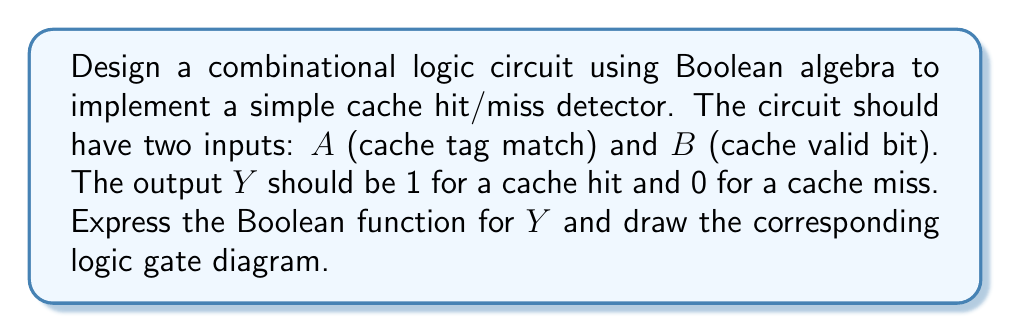Give your solution to this math problem. Let's approach this step-by-step:

1. Understand the cache hit condition:
   A cache hit occurs when the cache tag matches ($A = 1$) AND the cache line is valid ($B = 1$).

2. Express this as a Boolean function:
   $Y = A \cdot B$

3. This is a simple AND operation between inputs $A$ and $B$.

4. The logic gate diagram for this function would be a single AND gate with two inputs:

[asy]
import geometry;

pair A = (0,20), B = (0,0), Y = (40,10);
draw(A--Y,arrow=Arrow(TeXHead));
draw(B--Y,arrow=Arrow(TeXHead));
draw(circle(Y,10));

label("A", A, W);
label("B", B, W);
label("Y", (50,10), E);

draw((30,10)--(35,10));
draw((35,5)--(35,15));
[/asy]

5. Truth table for verification:

   | A | B | Y |
   |---|---|---|
   | 0 | 0 | 0 |
   | 0 | 1 | 0 |
   | 1 | 0 | 0 |
   | 1 | 1 | 1 |

This truth table confirms that $Y$ is 1 (cache hit) only when both $A$ and $B$ are 1.
Answer: $Y = A \cdot B$ 